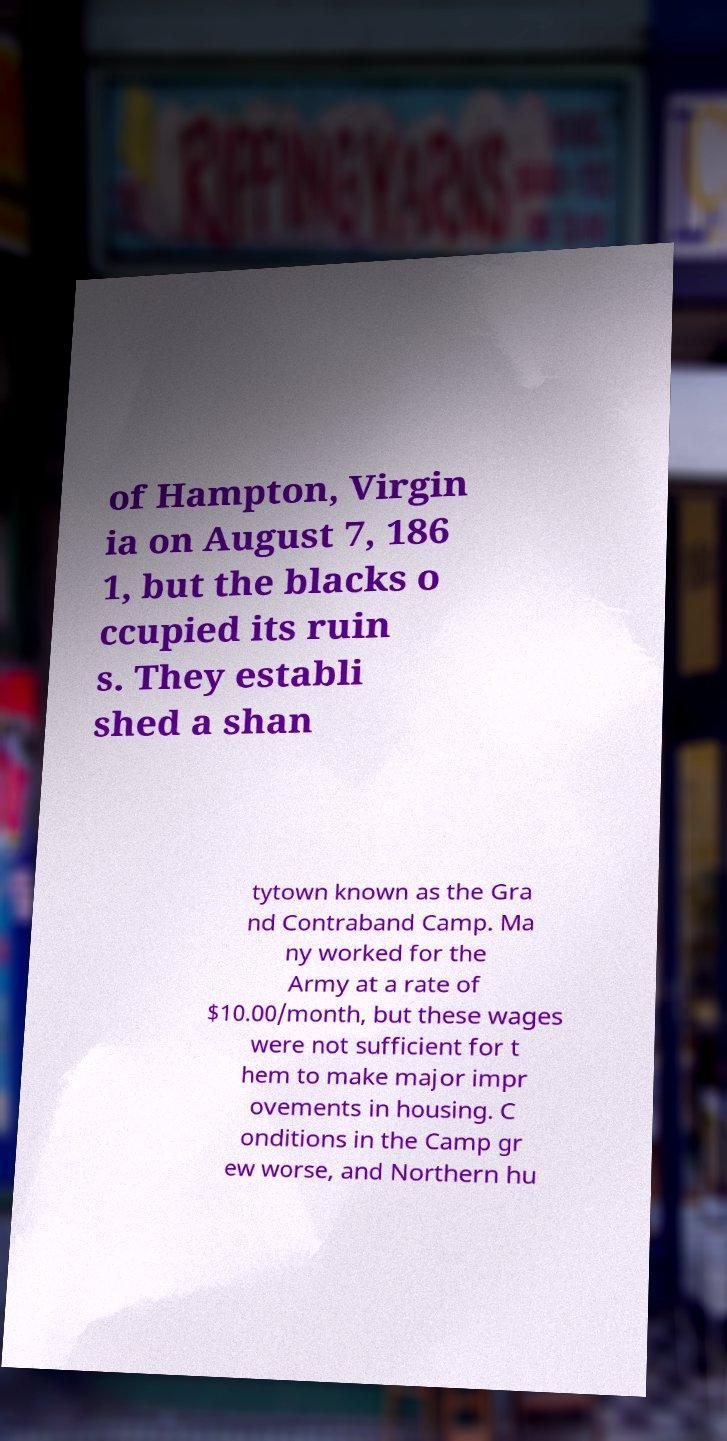For documentation purposes, I need the text within this image transcribed. Could you provide that? of Hampton, Virgin ia on August 7, 186 1, but the blacks o ccupied its ruin s. They establi shed a shan tytown known as the Gra nd Contraband Camp. Ma ny worked for the Army at a rate of $10.00/month, but these wages were not sufficient for t hem to make major impr ovements in housing. C onditions in the Camp gr ew worse, and Northern hu 